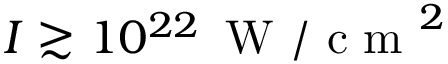<formula> <loc_0><loc_0><loc_500><loc_500>I \gtrsim 1 0 ^ { 2 2 } \, W / c m ^ { 2 }</formula> 